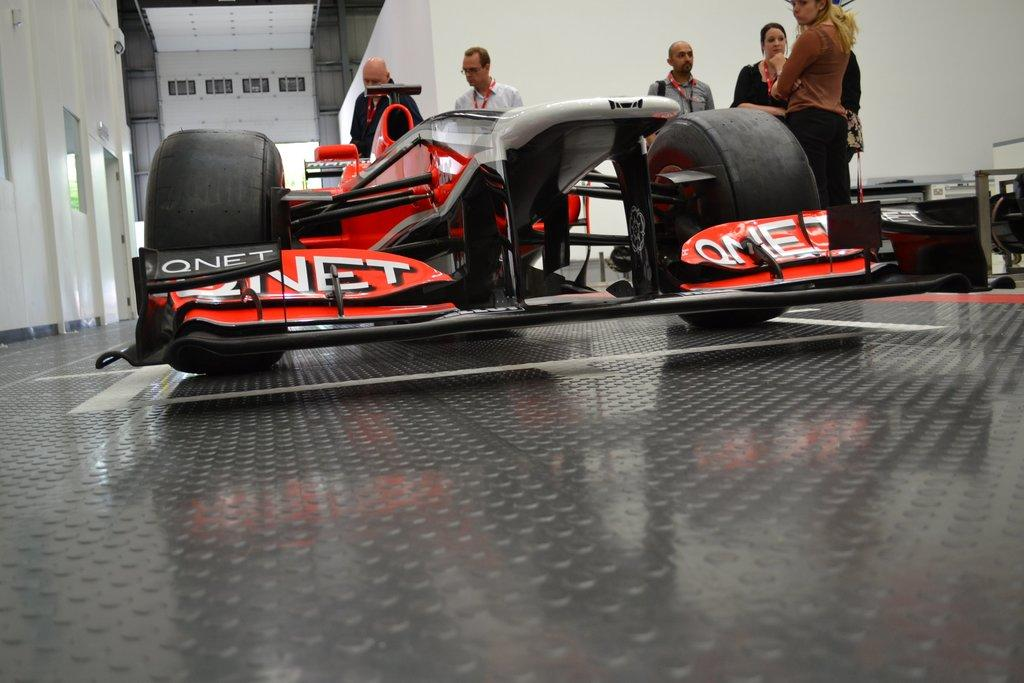What is on the floor in the image? There is a vehicle on the floor in the image. What can be seen in the background of the image? There are people standing and a wall visible in the background of the image. Can you describe any other objects or elements in the image? There are other unspecified objects or elements in the image. How many roots can be seen growing from the vehicle in the image? There are no roots visible in the image, as it features a vehicle on the floor and not a plant. 